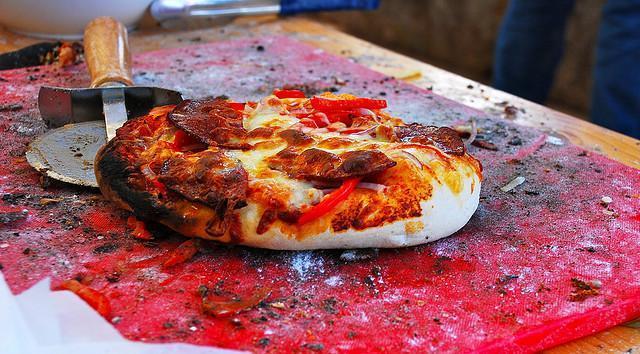Verify the accuracy of this image caption: "The bowl is under the pizza.".
Answer yes or no. No. 